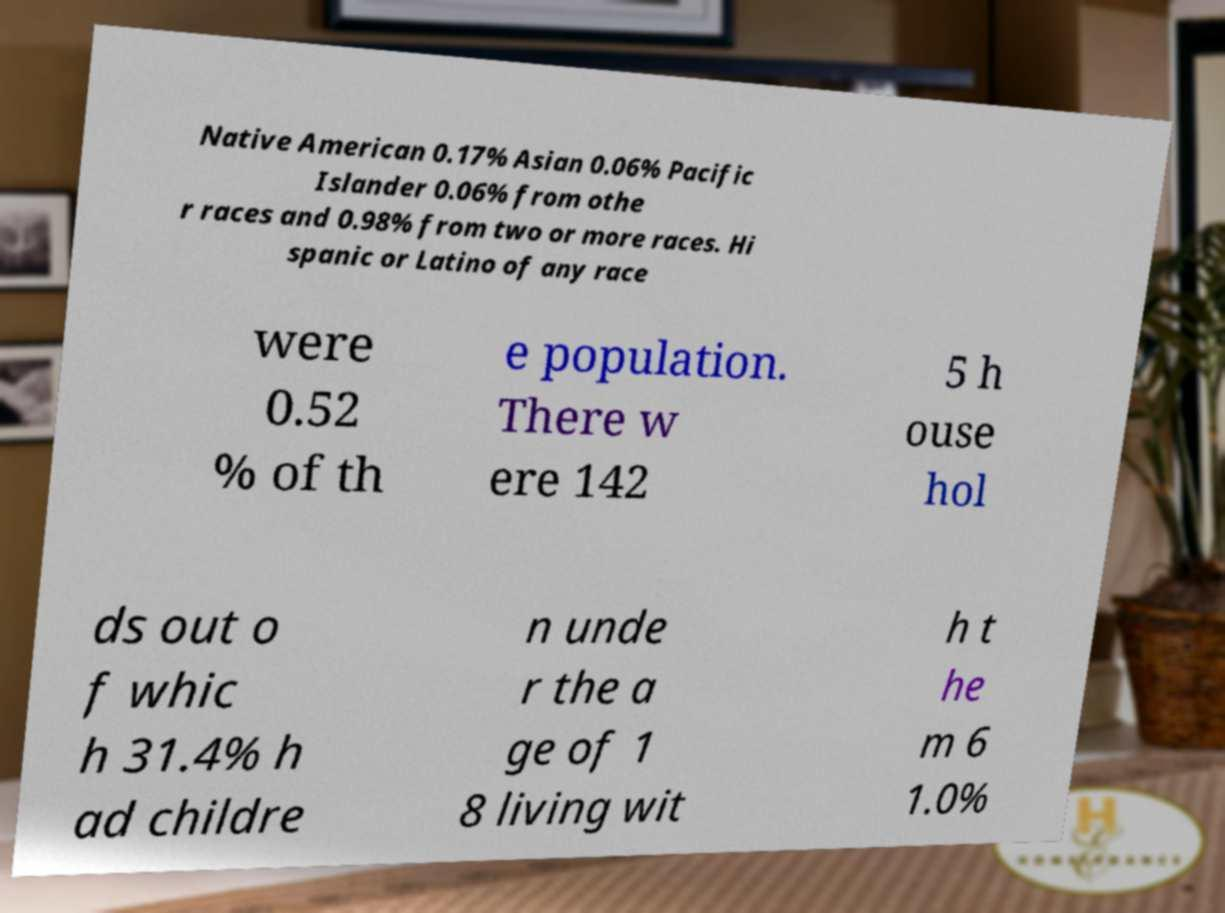Can you read and provide the text displayed in the image?This photo seems to have some interesting text. Can you extract and type it out for me? Native American 0.17% Asian 0.06% Pacific Islander 0.06% from othe r races and 0.98% from two or more races. Hi spanic or Latino of any race were 0.52 % of th e population. There w ere 142 5 h ouse hol ds out o f whic h 31.4% h ad childre n unde r the a ge of 1 8 living wit h t he m 6 1.0% 